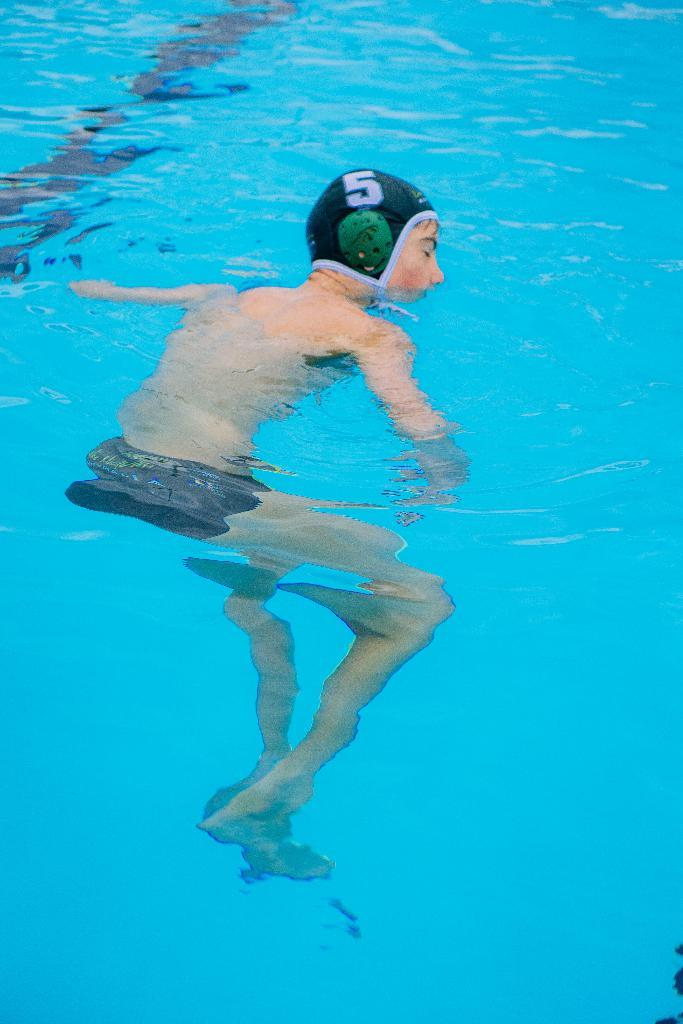What is the person in the image doing? The person is in the water. What protective gear is the person wearing? The person is wearing a helmet. What is the texture of the substance the person is standing on in the image? There is no information about the texture of the substance the person is standing on, as the facts only mention the person being in the water and wearing a helmet. 